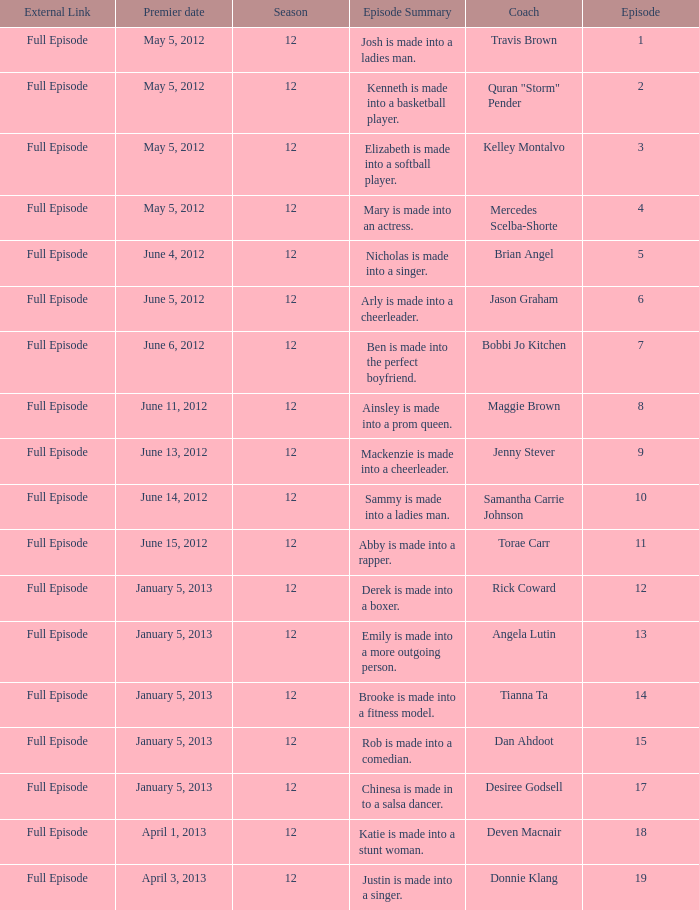Name the least episode for donnie klang 19.0. 